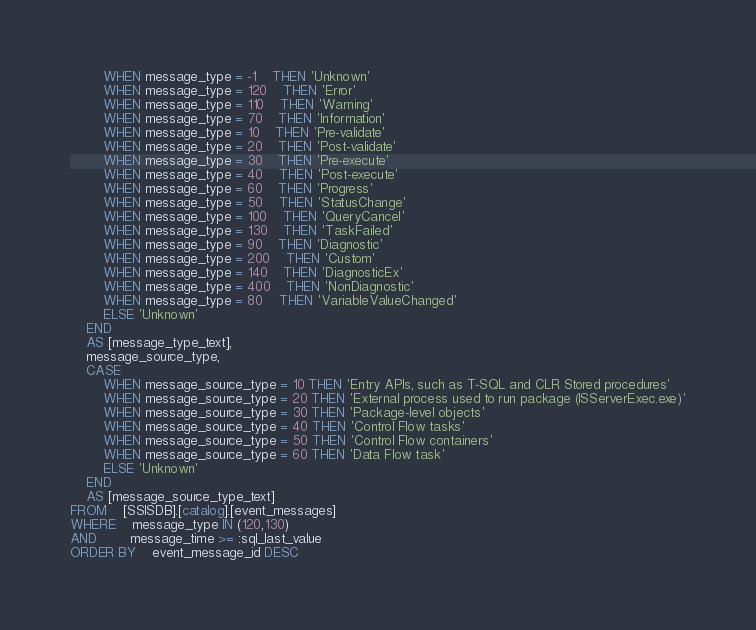<code> <loc_0><loc_0><loc_500><loc_500><_SQL_>		WHEN message_type = -1	THEN 'Unknown'
		WHEN message_type = 120	THEN 'Error'
		WHEN message_type = 110	THEN 'Warning'
		WHEN message_type = 70	THEN 'Information'
		WHEN message_type = 10	THEN 'Pre-validate'
		WHEN message_type = 20	THEN 'Post-validate'
		WHEN message_type = 30	THEN 'Pre-execute'
		WHEN message_type = 40	THEN 'Post-execute'
		WHEN message_type = 60	THEN 'Progress'
		WHEN message_type = 50	THEN 'StatusChange'
		WHEN message_type = 100	THEN 'QueryCancel'
		WHEN message_type = 130	THEN 'TaskFailed'
		WHEN message_type = 90	THEN 'Diagnostic'
		WHEN message_type = 200	THEN 'Custom'
		WHEN message_type = 140	THEN 'DiagnosticEx'
		WHEN message_type = 400	THEN 'NonDiagnostic'
		WHEN message_type = 80	THEN 'VariableValueChanged'
		ELSE 'Unknown' 
	END 
	AS [message_type_text],
	message_source_type,
	CASE 
		WHEN message_source_type = 10 THEN 'Entry APIs, such as T-SQL and CLR Stored procedures'
		WHEN message_source_type = 20 THEN 'External process used to run package (ISServerExec.exe)'
		WHEN message_source_type = 30 THEN 'Package-level objects'
		WHEN message_source_type = 40 THEN 'Control Flow tasks'
		WHEN message_source_type = 50 THEN 'Control Flow containers'
		WHEN message_source_type = 60 THEN 'Data Flow task'
		ELSE 'Unknown' 
	END 
	AS [message_source_type_text]
FROM	[SSISDB].[catalog].[event_messages] 
WHERE	message_type IN (120,130)
AND	 	message_time >= :sql_last_value
ORDER BY	event_message_id DESC

</code> 